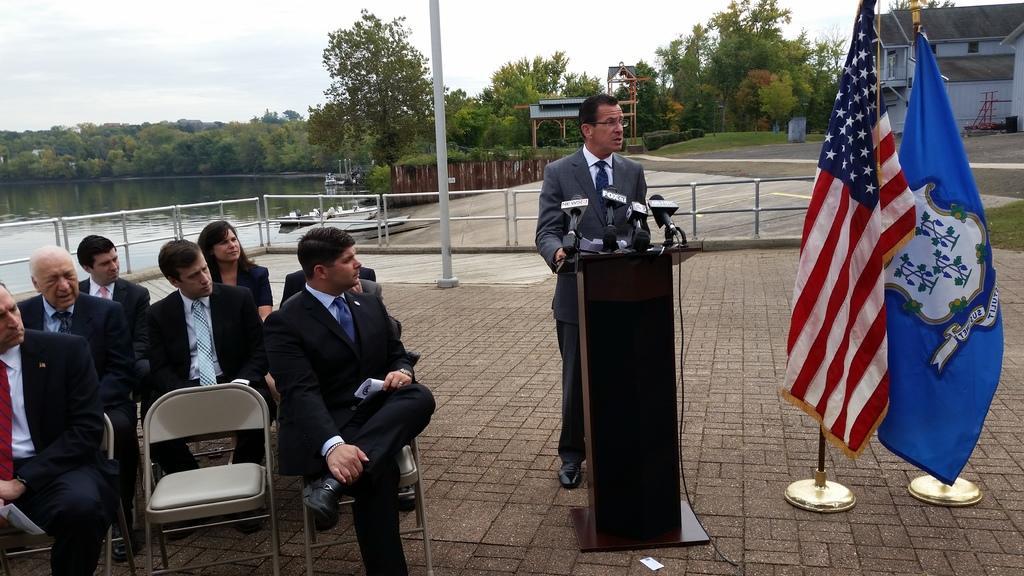Could you give a brief overview of what you see in this image? In this image there are few people sitting and one person standing. To the right, there are two flags. To the left, there is a small pond. In the background, there are many trees and plants. To the right, there is a building. In the middle, the man standing near the podium is wearing blue suit and talking in the mic. 